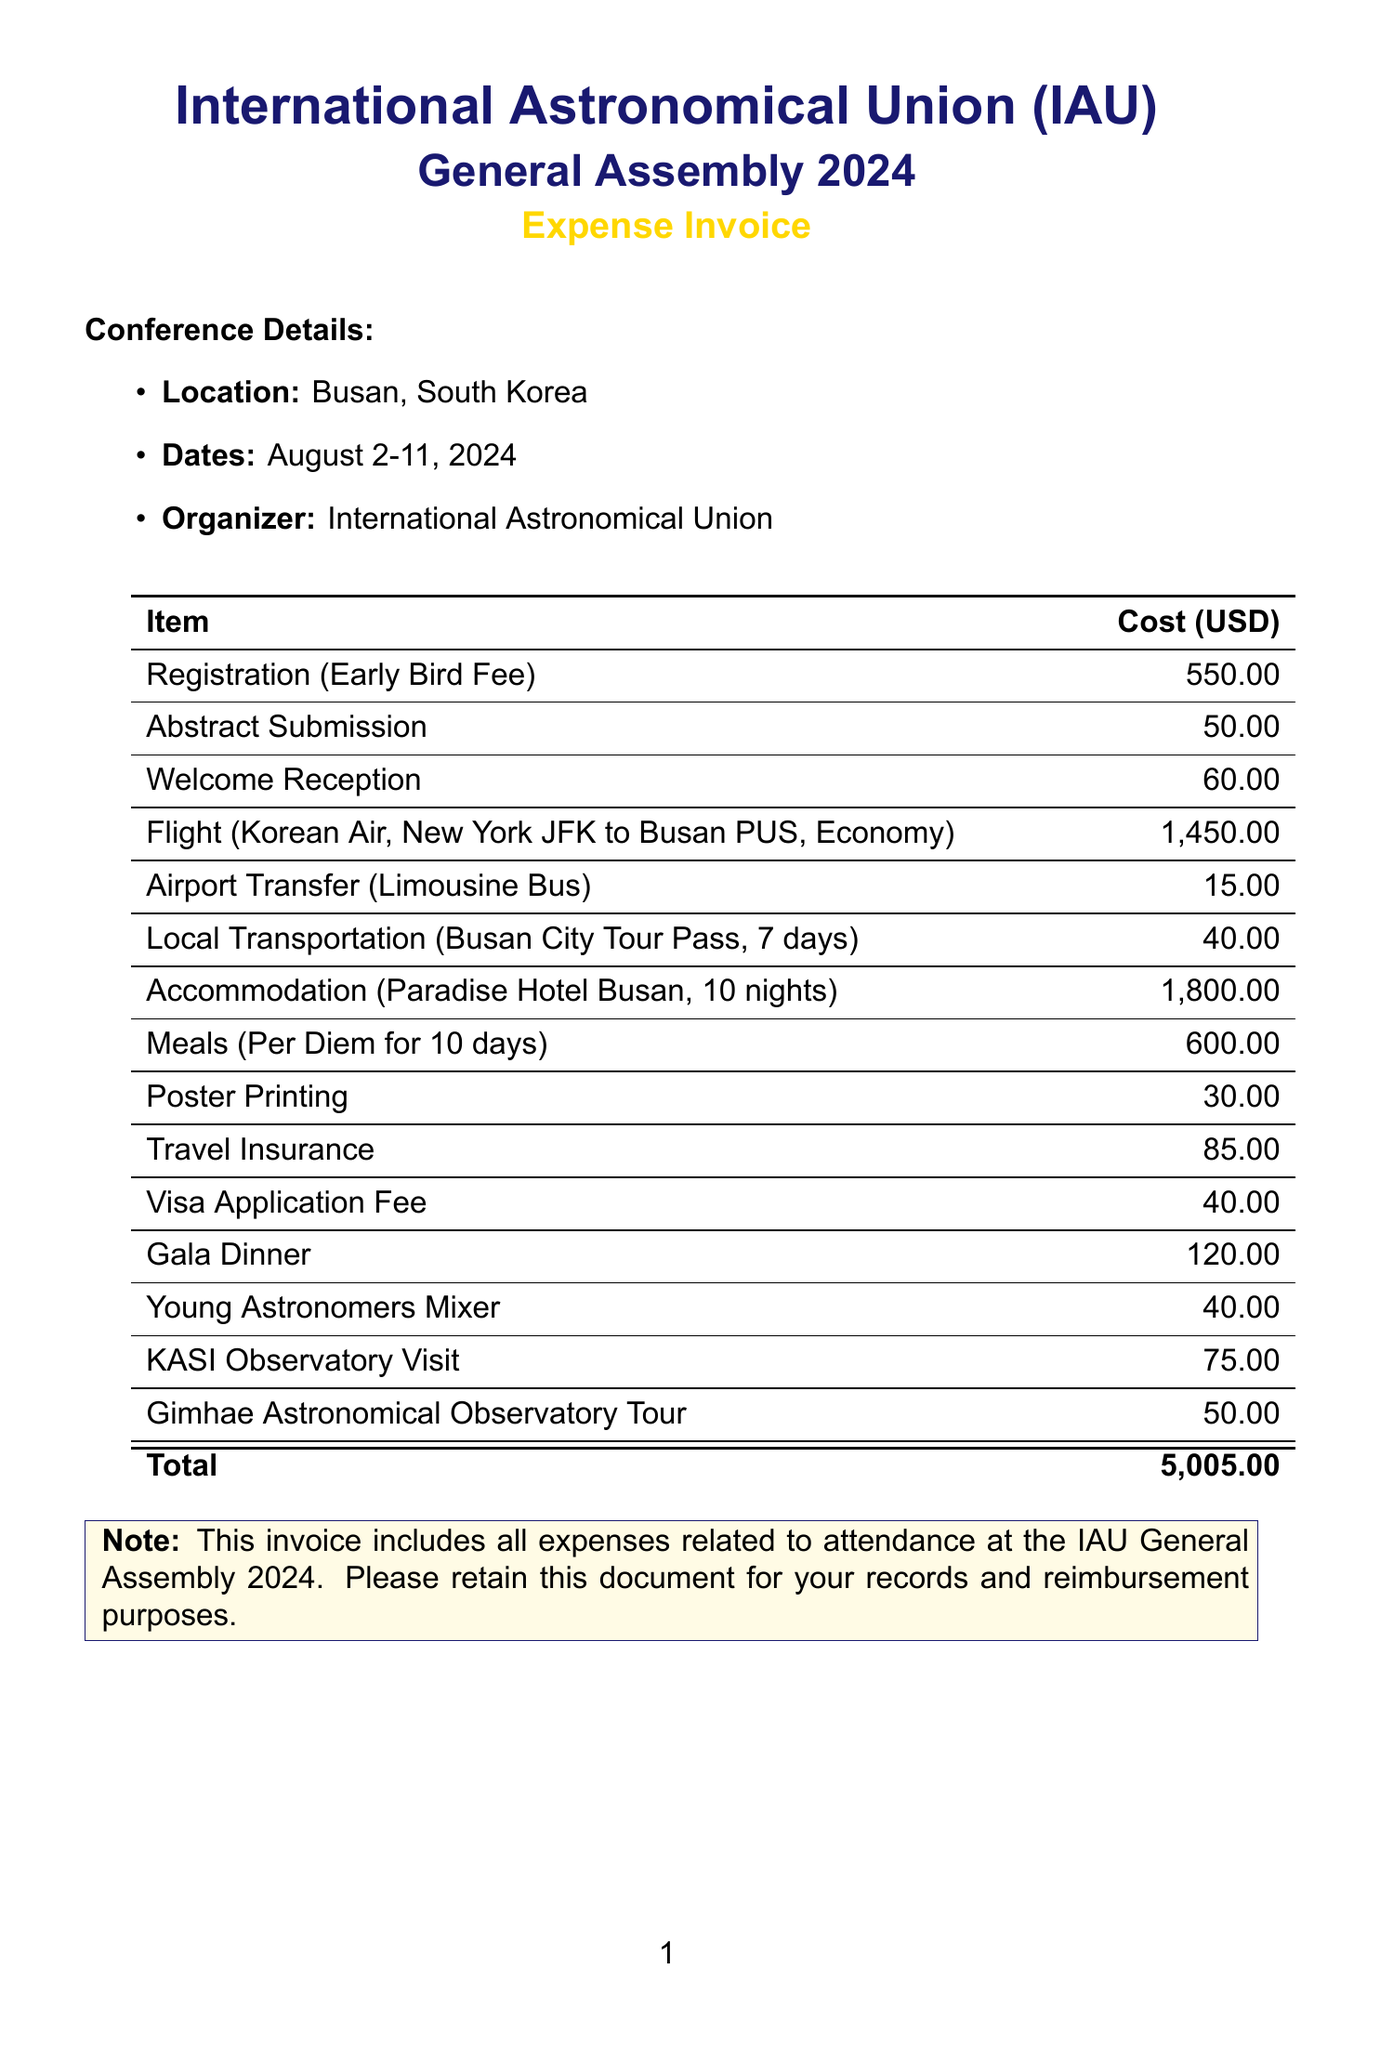What is the name of the conference? The document specifies the event as the "International Astronomical Union (IAU) General Assembly."
Answer: International Astronomical Union (IAU) General Assembly Where is the conference located? The invoice lists the location of the conference as "Busan, South Korea."
Answer: Busan, South Korea How much is the early bird registration fee? The document states that the early bird registration fee is "550."
Answer: 550 What is the total accommodation cost? The invoice shows the accommodation cost as "1,800" for ten nights at Paradise Hotel Busan.
Answer: 1,800 What type of local transportation is included? The document mentions a "Busan City Tour Pass" for local transportation.
Answer: Busan City Tour Pass How much is the visa application fee? The invoice indicates that the visa application fee is "$40."
Answer: 40 What is the duration of the local transportation pass? The document states that the pass is valid for "7 days."
Answer: 7 days What is the total amount of this invoice? The document clearly provides the total cost of attendance as "5,005."
Answer: 5,005 Which airline is used for the flight? The invoice specifies that the flight is with "Korean Air."
Answer: Korean Air 